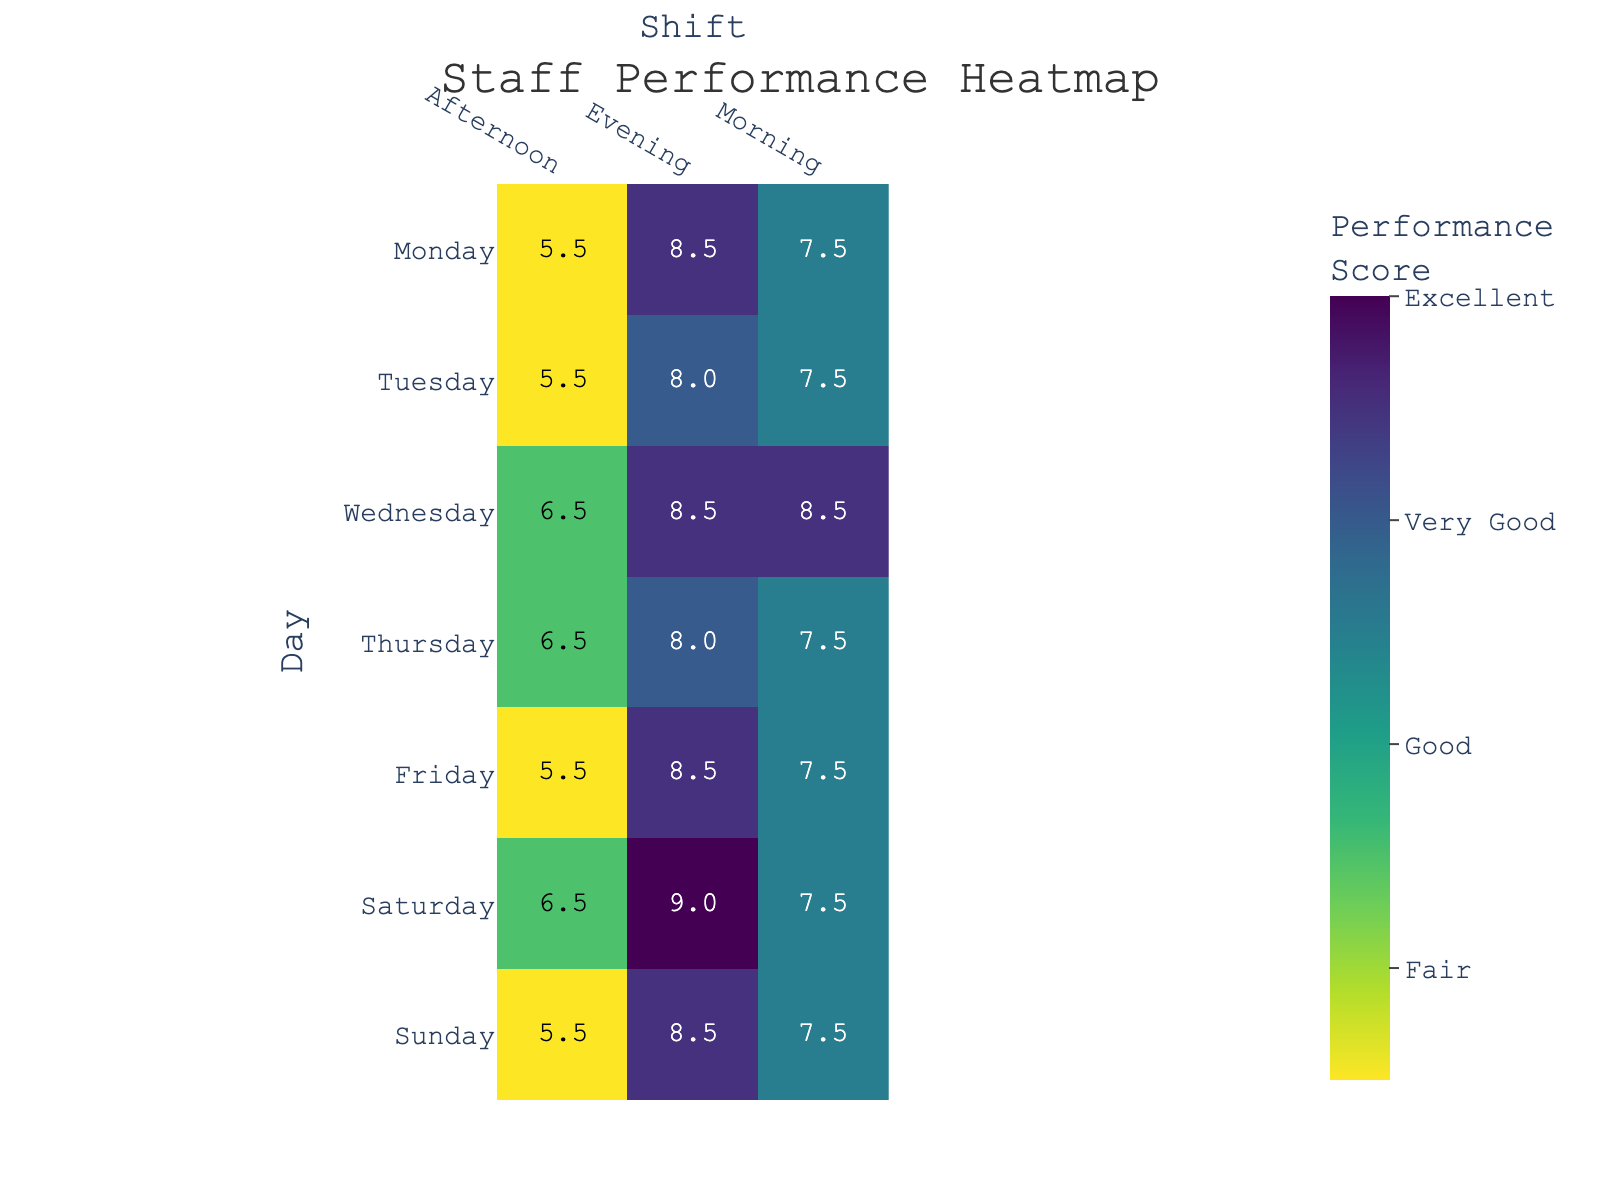What is the title of the heatmap? The title can be found at the top of the heatmap. It is written in a larger font size compared to other texts.
Answer: Staff Performance Heatmap Which shift has the highest average performance score on Tuesday? To find this, look at the Tuesday row and compare the scores for Morning, Afternoon, and Evening shifts in the heatmap. The numbers in each cell display the average performance.
Answer: Evening Which day has the lowest average performance score in the Morning shift? Compare the scores in the Morning column for all days in the heatmap. Find the lowest value.
Answer: Thursday What is the overall performance score for Emma Martinez on weekend evening shifts? Identify Emma Martinez's scores on Saturday and Sunday evening shifts, then sum them up. From the data, her scores are 9 (Saturday Evening) and 9 (Sunday Evening). Sum is 9 + 9 = 18.
Answer: 18 Is the performance score typically higher in the morning or evening shifts? Compare the overall trend in performance scores between the Morning and Evening columns in the heatmap. Observe the values and note which column generally has higher values.
Answer: Evening How does William Garcia's performance on Friday evening compare to Monday evening? Look at the heatmap for William Garcia's scores on Friday evening and Monday evening. Compare the two values.
Answer: Both are 9 On which day is the performance score for Michael Johnson the lowest? Find Michael Johnson’s scores for each day and determine the lowest value. From the data, his lowest score is on Tuesday (5).
Answer: Tuesday What is the difference in average performance scores between Wednesday and Sunday for Afternoon shifts? Compare the Wednesday and Sunday cells in the Afternoon column. The score for Wednesday is 6.5 and for Sunday is 5.5. The difference is 6.5 - 5.5 = 1.
Answer: 1 Which day of the week has the most consistent performance score across all shifts? Examine the scores for each day across Morning, Afternoon, and Evening shifts. The day with the least variation in its scores is the most consistent.
Answer: Wednesday 